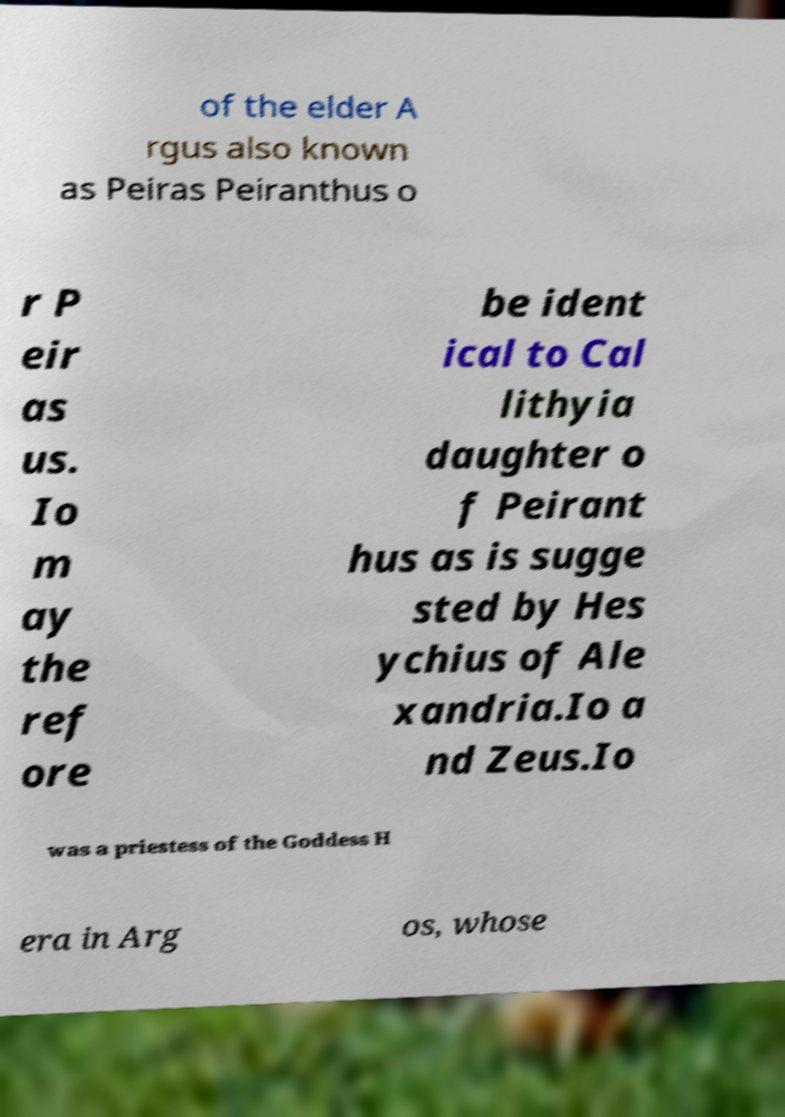Discuss the role of Hera as portrayed in the text in the image. Hera, in the text, is depicted in her typical role as the goddess of marriage and family, who often engages in acts driven by jealousy and revenge. In the story of Io, Hera's jealousy towards Zeus's affection for Io leads her to transform Io and set Argus as her guard, highlighting her complex character involving protectiveness and vindictiveness. 